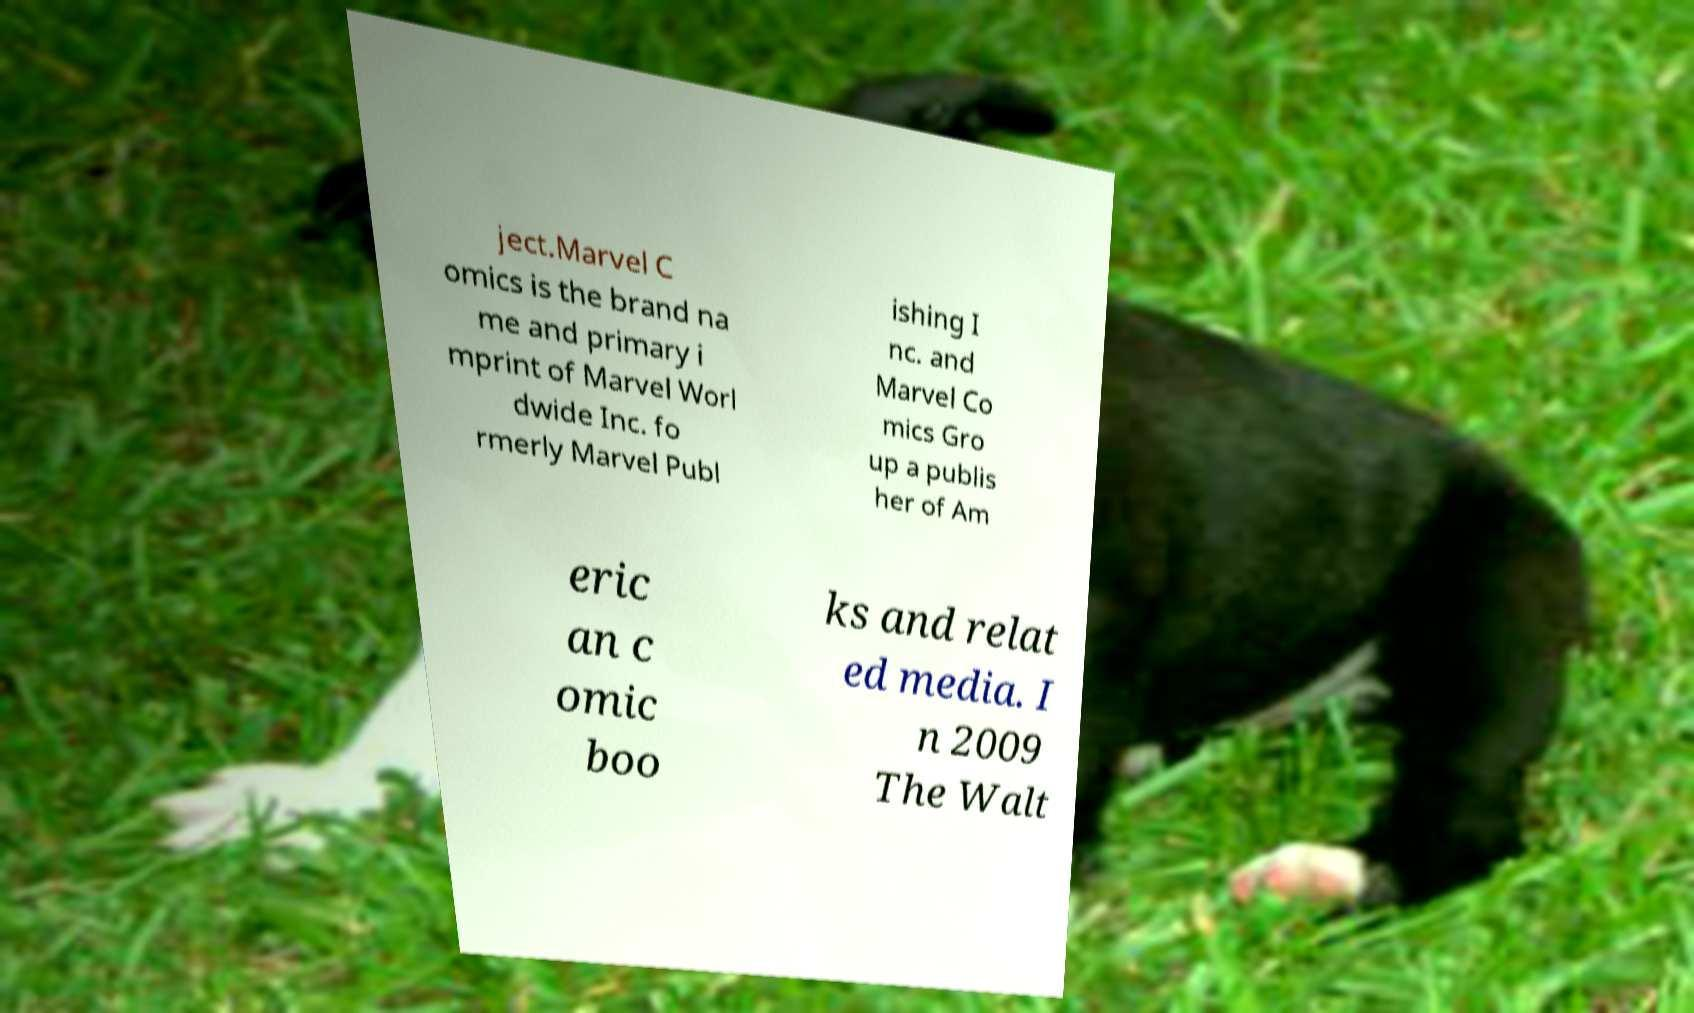Can you accurately transcribe the text from the provided image for me? ject.Marvel C omics is the brand na me and primary i mprint of Marvel Worl dwide Inc. fo rmerly Marvel Publ ishing I nc. and Marvel Co mics Gro up a publis her of Am eric an c omic boo ks and relat ed media. I n 2009 The Walt 